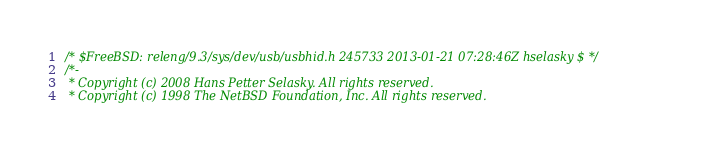<code> <loc_0><loc_0><loc_500><loc_500><_C_>/* $FreeBSD: releng/9.3/sys/dev/usb/usbhid.h 245733 2013-01-21 07:28:46Z hselasky $ */
/*-
 * Copyright (c) 2008 Hans Petter Selasky. All rights reserved.
 * Copyright (c) 1998 The NetBSD Foundation, Inc. All rights reserved.</code> 